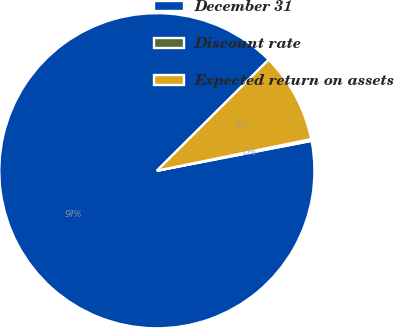<chart> <loc_0><loc_0><loc_500><loc_500><pie_chart><fcel>December 31<fcel>Discount rate<fcel>Expected return on assets<nl><fcel>90.59%<fcel>0.18%<fcel>9.23%<nl></chart> 